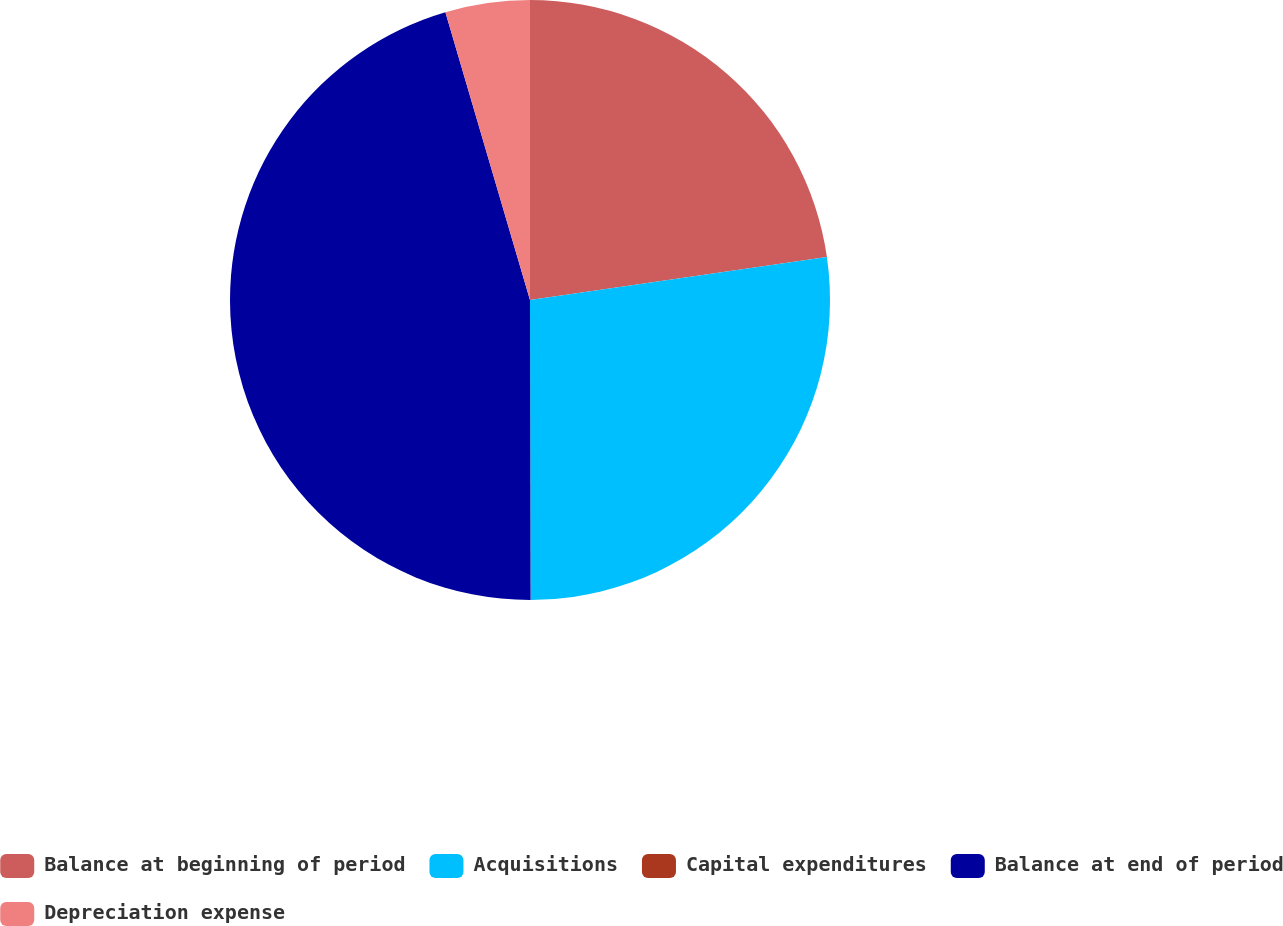Convert chart to OTSL. <chart><loc_0><loc_0><loc_500><loc_500><pie_chart><fcel>Balance at beginning of period<fcel>Acquisitions<fcel>Capital expenditures<fcel>Balance at end of period<fcel>Depreciation expense<nl><fcel>22.71%<fcel>27.26%<fcel>0.0%<fcel>45.48%<fcel>4.55%<nl></chart> 